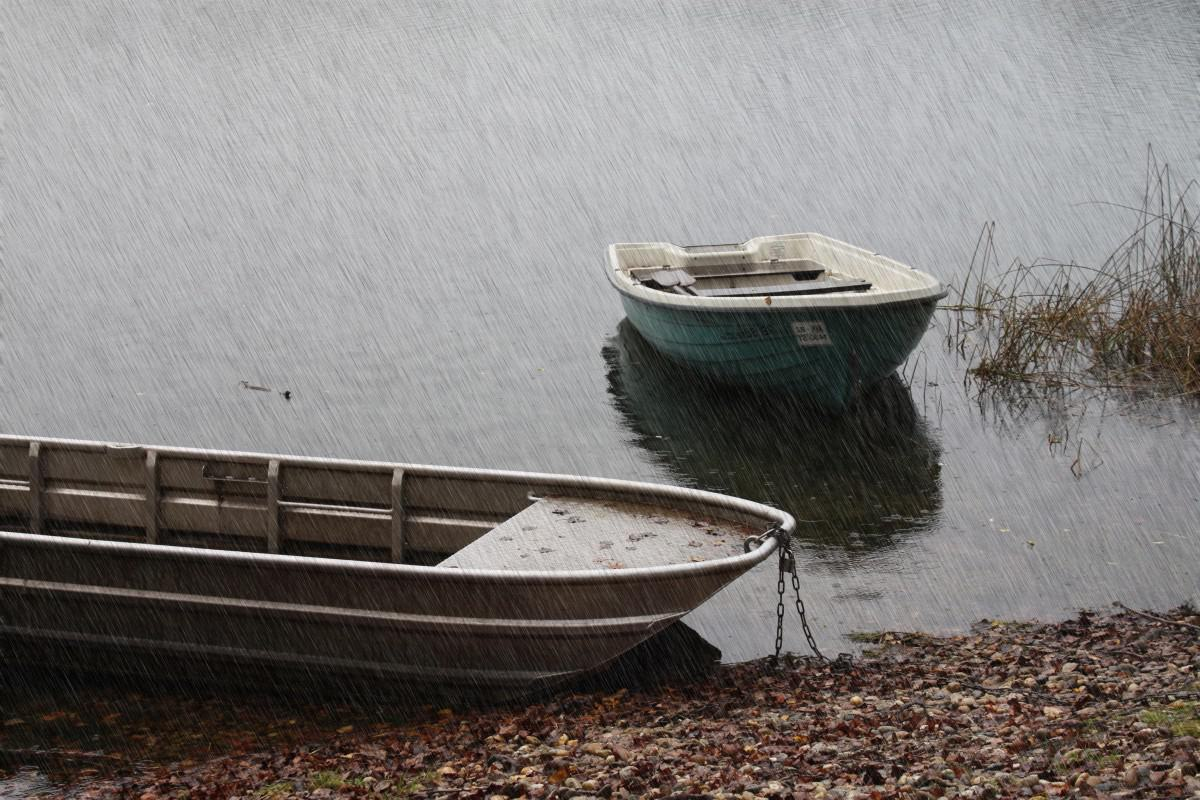Can you describe the environment around the boats? The boats are situated in what looks to be a tranquil, natural setting, likely a lake or calm river. The shore is littered with small stones, leaves, and a bit of vegetation, indicating the season might be autumn. There's a metal rail partially visible, perhaps part of a dock or boat launch area. 